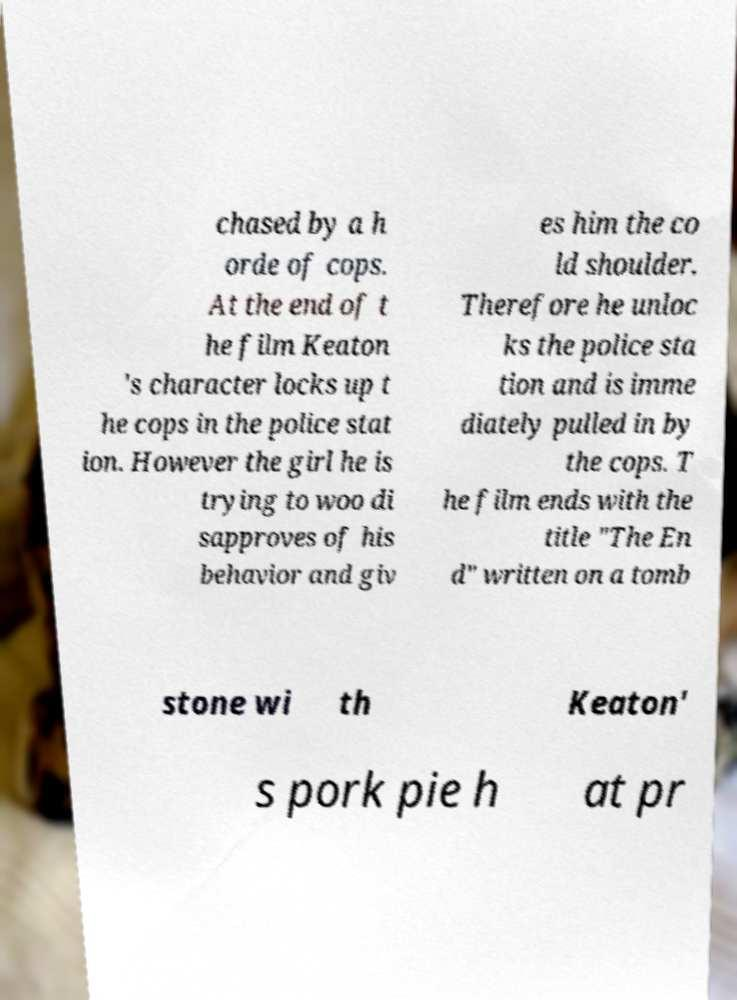For documentation purposes, I need the text within this image transcribed. Could you provide that? chased by a h orde of cops. At the end of t he film Keaton 's character locks up t he cops in the police stat ion. However the girl he is trying to woo di sapproves of his behavior and giv es him the co ld shoulder. Therefore he unloc ks the police sta tion and is imme diately pulled in by the cops. T he film ends with the title "The En d" written on a tomb stone wi th Keaton' s pork pie h at pr 